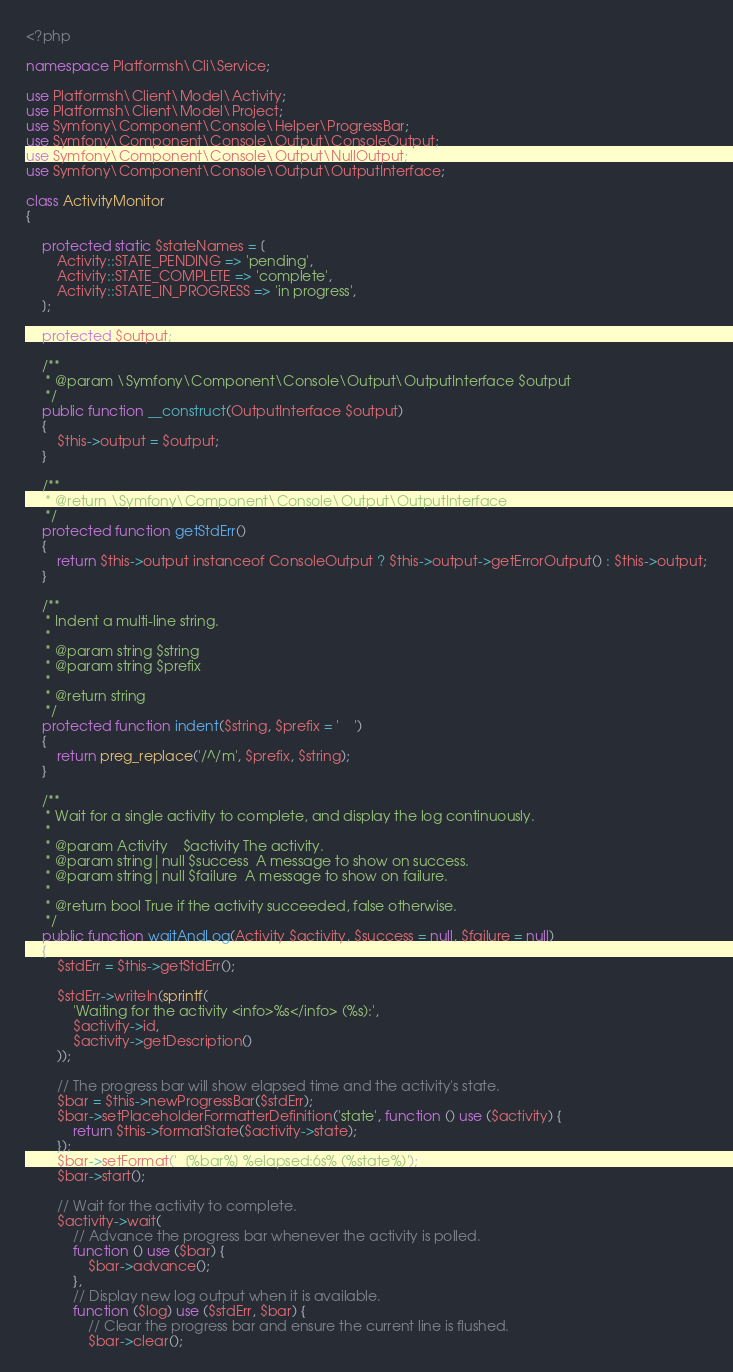<code> <loc_0><loc_0><loc_500><loc_500><_PHP_><?php

namespace Platformsh\Cli\Service;

use Platformsh\Client\Model\Activity;
use Platformsh\Client\Model\Project;
use Symfony\Component\Console\Helper\ProgressBar;
use Symfony\Component\Console\Output\ConsoleOutput;
use Symfony\Component\Console\Output\NullOutput;
use Symfony\Component\Console\Output\OutputInterface;

class ActivityMonitor
{

    protected static $stateNames = [
        Activity::STATE_PENDING => 'pending',
        Activity::STATE_COMPLETE => 'complete',
        Activity::STATE_IN_PROGRESS => 'in progress',
    ];

    protected $output;

    /**
     * @param \Symfony\Component\Console\Output\OutputInterface $output
     */
    public function __construct(OutputInterface $output)
    {
        $this->output = $output;
    }

    /**
     * @return \Symfony\Component\Console\Output\OutputInterface
     */
    protected function getStdErr()
    {
        return $this->output instanceof ConsoleOutput ? $this->output->getErrorOutput() : $this->output;
    }

    /**
     * Indent a multi-line string.
     *
     * @param string $string
     * @param string $prefix
     *
     * @return string
     */
    protected function indent($string, $prefix = '    ')
    {
        return preg_replace('/^/m', $prefix, $string);
    }

    /**
     * Wait for a single activity to complete, and display the log continuously.
     *
     * @param Activity    $activity The activity.
     * @param string|null $success  A message to show on success.
     * @param string|null $failure  A message to show on failure.
     *
     * @return bool True if the activity succeeded, false otherwise.
     */
    public function waitAndLog(Activity $activity, $success = null, $failure = null)
    {
        $stdErr = $this->getStdErr();

        $stdErr->writeln(sprintf(
            'Waiting for the activity <info>%s</info> (%s):',
            $activity->id,
            $activity->getDescription()
        ));

        // The progress bar will show elapsed time and the activity's state.
        $bar = $this->newProgressBar($stdErr);
        $bar->setPlaceholderFormatterDefinition('state', function () use ($activity) {
            return $this->formatState($activity->state);
        });
        $bar->setFormat('  [%bar%] %elapsed:6s% (%state%)');
        $bar->start();

        // Wait for the activity to complete.
        $activity->wait(
            // Advance the progress bar whenever the activity is polled.
            function () use ($bar) {
                $bar->advance();
            },
            // Display new log output when it is available.
            function ($log) use ($stdErr, $bar) {
                // Clear the progress bar and ensure the current line is flushed.
                $bar->clear();</code> 